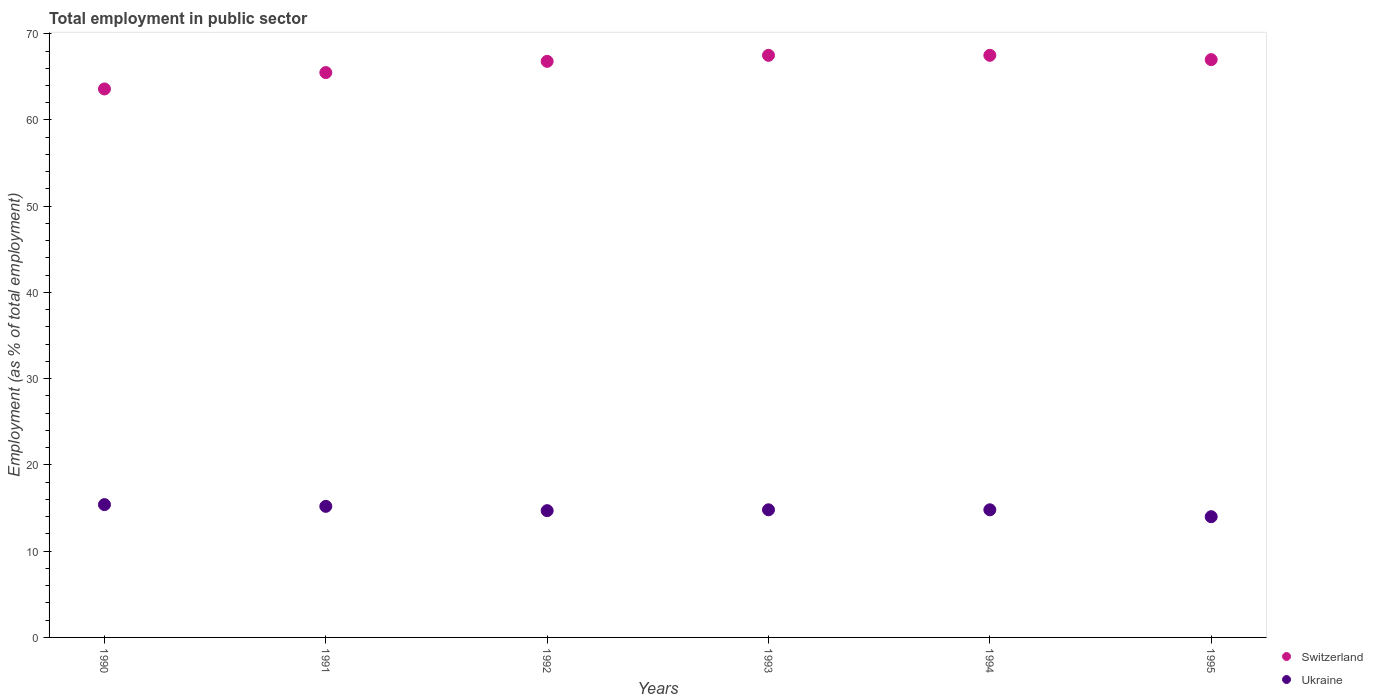Is the number of dotlines equal to the number of legend labels?
Your answer should be very brief. Yes. What is the employment in public sector in Ukraine in 1992?
Provide a succinct answer. 14.7. Across all years, what is the maximum employment in public sector in Ukraine?
Your response must be concise. 15.4. Across all years, what is the minimum employment in public sector in Ukraine?
Your response must be concise. 14. What is the total employment in public sector in Ukraine in the graph?
Your response must be concise. 88.9. What is the difference between the employment in public sector in Ukraine in 1990 and that in 1992?
Your answer should be compact. 0.7. What is the difference between the employment in public sector in Ukraine in 1992 and the employment in public sector in Switzerland in 1994?
Provide a short and direct response. -52.8. What is the average employment in public sector in Ukraine per year?
Ensure brevity in your answer.  14.82. In the year 1993, what is the difference between the employment in public sector in Switzerland and employment in public sector in Ukraine?
Offer a terse response. 52.7. What is the ratio of the employment in public sector in Switzerland in 1993 to that in 1995?
Your response must be concise. 1.01. Is the difference between the employment in public sector in Switzerland in 1991 and 1993 greater than the difference between the employment in public sector in Ukraine in 1991 and 1993?
Ensure brevity in your answer.  No. What is the difference between the highest and the second highest employment in public sector in Switzerland?
Keep it short and to the point. 0. What is the difference between the highest and the lowest employment in public sector in Ukraine?
Your answer should be very brief. 1.4. In how many years, is the employment in public sector in Switzerland greater than the average employment in public sector in Switzerland taken over all years?
Provide a short and direct response. 4. Is the sum of the employment in public sector in Switzerland in 1993 and 1994 greater than the maximum employment in public sector in Ukraine across all years?
Your answer should be compact. Yes. Does the employment in public sector in Switzerland monotonically increase over the years?
Keep it short and to the point. No. Is the employment in public sector in Switzerland strictly greater than the employment in public sector in Ukraine over the years?
Give a very brief answer. Yes. What is the difference between two consecutive major ticks on the Y-axis?
Ensure brevity in your answer.  10. Are the values on the major ticks of Y-axis written in scientific E-notation?
Give a very brief answer. No. Does the graph contain any zero values?
Keep it short and to the point. No. Where does the legend appear in the graph?
Provide a succinct answer. Bottom right. How are the legend labels stacked?
Provide a short and direct response. Vertical. What is the title of the graph?
Provide a succinct answer. Total employment in public sector. What is the label or title of the Y-axis?
Offer a very short reply. Employment (as % of total employment). What is the Employment (as % of total employment) of Switzerland in 1990?
Your answer should be very brief. 63.6. What is the Employment (as % of total employment) of Ukraine in 1990?
Keep it short and to the point. 15.4. What is the Employment (as % of total employment) of Switzerland in 1991?
Provide a succinct answer. 65.5. What is the Employment (as % of total employment) in Ukraine in 1991?
Ensure brevity in your answer.  15.2. What is the Employment (as % of total employment) in Switzerland in 1992?
Give a very brief answer. 66.8. What is the Employment (as % of total employment) in Ukraine in 1992?
Offer a very short reply. 14.7. What is the Employment (as % of total employment) of Switzerland in 1993?
Your answer should be compact. 67.5. What is the Employment (as % of total employment) in Ukraine in 1993?
Ensure brevity in your answer.  14.8. What is the Employment (as % of total employment) in Switzerland in 1994?
Provide a succinct answer. 67.5. What is the Employment (as % of total employment) of Ukraine in 1994?
Give a very brief answer. 14.8. What is the Employment (as % of total employment) in Switzerland in 1995?
Your response must be concise. 67. What is the Employment (as % of total employment) of Ukraine in 1995?
Your answer should be very brief. 14. Across all years, what is the maximum Employment (as % of total employment) in Switzerland?
Ensure brevity in your answer.  67.5. Across all years, what is the maximum Employment (as % of total employment) in Ukraine?
Provide a succinct answer. 15.4. Across all years, what is the minimum Employment (as % of total employment) of Switzerland?
Offer a terse response. 63.6. Across all years, what is the minimum Employment (as % of total employment) in Ukraine?
Your answer should be compact. 14. What is the total Employment (as % of total employment) of Switzerland in the graph?
Keep it short and to the point. 397.9. What is the total Employment (as % of total employment) of Ukraine in the graph?
Keep it short and to the point. 88.9. What is the difference between the Employment (as % of total employment) of Switzerland in 1990 and that in 1992?
Give a very brief answer. -3.2. What is the difference between the Employment (as % of total employment) in Switzerland in 1990 and that in 1993?
Give a very brief answer. -3.9. What is the difference between the Employment (as % of total employment) of Switzerland in 1990 and that in 1994?
Your response must be concise. -3.9. What is the difference between the Employment (as % of total employment) of Switzerland in 1991 and that in 1993?
Offer a very short reply. -2. What is the difference between the Employment (as % of total employment) in Switzerland in 1992 and that in 1993?
Your answer should be very brief. -0.7. What is the difference between the Employment (as % of total employment) in Ukraine in 1992 and that in 1993?
Offer a very short reply. -0.1. What is the difference between the Employment (as % of total employment) in Ukraine in 1992 and that in 1994?
Offer a very short reply. -0.1. What is the difference between the Employment (as % of total employment) in Switzerland in 1992 and that in 1995?
Your response must be concise. -0.2. What is the difference between the Employment (as % of total employment) in Switzerland in 1993 and that in 1994?
Your answer should be compact. 0. What is the difference between the Employment (as % of total employment) of Switzerland in 1993 and that in 1995?
Provide a short and direct response. 0.5. What is the difference between the Employment (as % of total employment) of Switzerland in 1994 and that in 1995?
Make the answer very short. 0.5. What is the difference between the Employment (as % of total employment) of Ukraine in 1994 and that in 1995?
Your answer should be very brief. 0.8. What is the difference between the Employment (as % of total employment) of Switzerland in 1990 and the Employment (as % of total employment) of Ukraine in 1991?
Offer a terse response. 48.4. What is the difference between the Employment (as % of total employment) of Switzerland in 1990 and the Employment (as % of total employment) of Ukraine in 1992?
Provide a short and direct response. 48.9. What is the difference between the Employment (as % of total employment) of Switzerland in 1990 and the Employment (as % of total employment) of Ukraine in 1993?
Your response must be concise. 48.8. What is the difference between the Employment (as % of total employment) of Switzerland in 1990 and the Employment (as % of total employment) of Ukraine in 1994?
Offer a very short reply. 48.8. What is the difference between the Employment (as % of total employment) of Switzerland in 1990 and the Employment (as % of total employment) of Ukraine in 1995?
Provide a succinct answer. 49.6. What is the difference between the Employment (as % of total employment) of Switzerland in 1991 and the Employment (as % of total employment) of Ukraine in 1992?
Provide a short and direct response. 50.8. What is the difference between the Employment (as % of total employment) of Switzerland in 1991 and the Employment (as % of total employment) of Ukraine in 1993?
Make the answer very short. 50.7. What is the difference between the Employment (as % of total employment) in Switzerland in 1991 and the Employment (as % of total employment) in Ukraine in 1994?
Your response must be concise. 50.7. What is the difference between the Employment (as % of total employment) in Switzerland in 1991 and the Employment (as % of total employment) in Ukraine in 1995?
Your answer should be compact. 51.5. What is the difference between the Employment (as % of total employment) of Switzerland in 1992 and the Employment (as % of total employment) of Ukraine in 1994?
Your answer should be very brief. 52. What is the difference between the Employment (as % of total employment) of Switzerland in 1992 and the Employment (as % of total employment) of Ukraine in 1995?
Offer a very short reply. 52.8. What is the difference between the Employment (as % of total employment) of Switzerland in 1993 and the Employment (as % of total employment) of Ukraine in 1994?
Provide a short and direct response. 52.7. What is the difference between the Employment (as % of total employment) in Switzerland in 1993 and the Employment (as % of total employment) in Ukraine in 1995?
Offer a very short reply. 53.5. What is the difference between the Employment (as % of total employment) of Switzerland in 1994 and the Employment (as % of total employment) of Ukraine in 1995?
Give a very brief answer. 53.5. What is the average Employment (as % of total employment) of Switzerland per year?
Give a very brief answer. 66.32. What is the average Employment (as % of total employment) in Ukraine per year?
Ensure brevity in your answer.  14.82. In the year 1990, what is the difference between the Employment (as % of total employment) of Switzerland and Employment (as % of total employment) of Ukraine?
Make the answer very short. 48.2. In the year 1991, what is the difference between the Employment (as % of total employment) of Switzerland and Employment (as % of total employment) of Ukraine?
Provide a succinct answer. 50.3. In the year 1992, what is the difference between the Employment (as % of total employment) in Switzerland and Employment (as % of total employment) in Ukraine?
Your response must be concise. 52.1. In the year 1993, what is the difference between the Employment (as % of total employment) in Switzerland and Employment (as % of total employment) in Ukraine?
Make the answer very short. 52.7. In the year 1994, what is the difference between the Employment (as % of total employment) in Switzerland and Employment (as % of total employment) in Ukraine?
Offer a terse response. 52.7. What is the ratio of the Employment (as % of total employment) of Ukraine in 1990 to that in 1991?
Your answer should be very brief. 1.01. What is the ratio of the Employment (as % of total employment) of Switzerland in 1990 to that in 1992?
Provide a succinct answer. 0.95. What is the ratio of the Employment (as % of total employment) in Ukraine in 1990 to that in 1992?
Offer a terse response. 1.05. What is the ratio of the Employment (as % of total employment) of Switzerland in 1990 to that in 1993?
Provide a short and direct response. 0.94. What is the ratio of the Employment (as % of total employment) of Ukraine in 1990 to that in 1993?
Provide a short and direct response. 1.04. What is the ratio of the Employment (as % of total employment) in Switzerland in 1990 to that in 1994?
Make the answer very short. 0.94. What is the ratio of the Employment (as % of total employment) of Ukraine in 1990 to that in 1994?
Provide a short and direct response. 1.04. What is the ratio of the Employment (as % of total employment) in Switzerland in 1990 to that in 1995?
Offer a terse response. 0.95. What is the ratio of the Employment (as % of total employment) in Ukraine in 1990 to that in 1995?
Provide a short and direct response. 1.1. What is the ratio of the Employment (as % of total employment) of Switzerland in 1991 to that in 1992?
Your response must be concise. 0.98. What is the ratio of the Employment (as % of total employment) of Ukraine in 1991 to that in 1992?
Ensure brevity in your answer.  1.03. What is the ratio of the Employment (as % of total employment) in Switzerland in 1991 to that in 1993?
Your answer should be very brief. 0.97. What is the ratio of the Employment (as % of total employment) of Switzerland in 1991 to that in 1994?
Give a very brief answer. 0.97. What is the ratio of the Employment (as % of total employment) in Switzerland in 1991 to that in 1995?
Your answer should be very brief. 0.98. What is the ratio of the Employment (as % of total employment) of Ukraine in 1991 to that in 1995?
Offer a terse response. 1.09. What is the ratio of the Employment (as % of total employment) in Switzerland in 1992 to that in 1993?
Offer a very short reply. 0.99. What is the ratio of the Employment (as % of total employment) in Ukraine in 1992 to that in 1993?
Provide a succinct answer. 0.99. What is the ratio of the Employment (as % of total employment) in Ukraine in 1992 to that in 1995?
Keep it short and to the point. 1.05. What is the ratio of the Employment (as % of total employment) in Switzerland in 1993 to that in 1994?
Provide a short and direct response. 1. What is the ratio of the Employment (as % of total employment) of Ukraine in 1993 to that in 1994?
Your answer should be compact. 1. What is the ratio of the Employment (as % of total employment) of Switzerland in 1993 to that in 1995?
Your response must be concise. 1.01. What is the ratio of the Employment (as % of total employment) in Ukraine in 1993 to that in 1995?
Give a very brief answer. 1.06. What is the ratio of the Employment (as % of total employment) of Switzerland in 1994 to that in 1995?
Your answer should be compact. 1.01. What is the ratio of the Employment (as % of total employment) in Ukraine in 1994 to that in 1995?
Make the answer very short. 1.06. What is the difference between the highest and the lowest Employment (as % of total employment) of Ukraine?
Your answer should be compact. 1.4. 